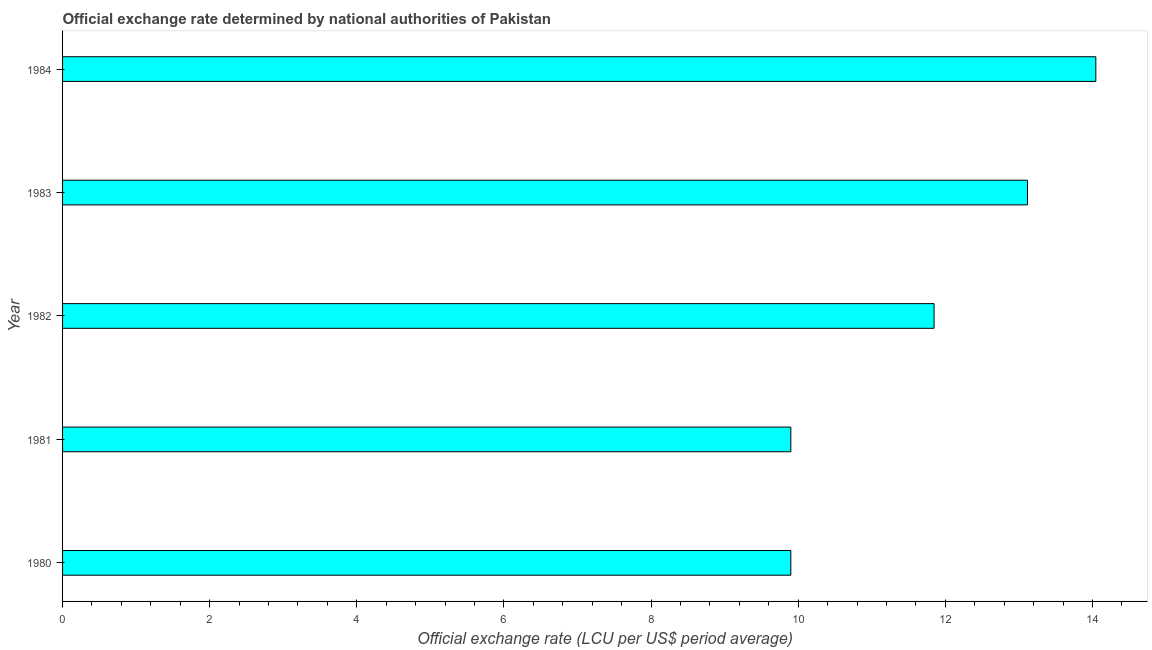Does the graph contain any zero values?
Your response must be concise. No. Does the graph contain grids?
Keep it short and to the point. No. What is the title of the graph?
Make the answer very short. Official exchange rate determined by national authorities of Pakistan. What is the label or title of the X-axis?
Make the answer very short. Official exchange rate (LCU per US$ period average). What is the label or title of the Y-axis?
Offer a very short reply. Year. What is the official exchange rate in 1984?
Provide a succinct answer. 14.05. Across all years, what is the maximum official exchange rate?
Your answer should be very brief. 14.05. Across all years, what is the minimum official exchange rate?
Provide a succinct answer. 9.9. In which year was the official exchange rate minimum?
Keep it short and to the point. 1980. What is the sum of the official exchange rate?
Offer a terse response. 58.81. What is the difference between the official exchange rate in 1981 and 1983?
Provide a succinct answer. -3.22. What is the average official exchange rate per year?
Provide a succinct answer. 11.76. What is the median official exchange rate?
Ensure brevity in your answer.  11.85. In how many years, is the official exchange rate greater than 6 ?
Keep it short and to the point. 5. Do a majority of the years between 1982 and 1981 (inclusive) have official exchange rate greater than 11.6 ?
Your answer should be very brief. No. What is the ratio of the official exchange rate in 1982 to that in 1984?
Give a very brief answer. 0.84. Is the difference between the official exchange rate in 1982 and 1983 greater than the difference between any two years?
Offer a very short reply. No. What is the difference between the highest and the second highest official exchange rate?
Provide a succinct answer. 0.93. Is the sum of the official exchange rate in 1981 and 1983 greater than the maximum official exchange rate across all years?
Offer a terse response. Yes. What is the difference between the highest and the lowest official exchange rate?
Keep it short and to the point. 4.15. In how many years, is the official exchange rate greater than the average official exchange rate taken over all years?
Ensure brevity in your answer.  3. How many bars are there?
Offer a very short reply. 5. What is the difference between two consecutive major ticks on the X-axis?
Your answer should be very brief. 2. What is the Official exchange rate (LCU per US$ period average) in 1981?
Offer a terse response. 9.9. What is the Official exchange rate (LCU per US$ period average) of 1982?
Ensure brevity in your answer.  11.85. What is the Official exchange rate (LCU per US$ period average) of 1983?
Make the answer very short. 13.12. What is the Official exchange rate (LCU per US$ period average) in 1984?
Your answer should be compact. 14.05. What is the difference between the Official exchange rate (LCU per US$ period average) in 1980 and 1981?
Offer a terse response. 0. What is the difference between the Official exchange rate (LCU per US$ period average) in 1980 and 1982?
Offer a terse response. -1.95. What is the difference between the Official exchange rate (LCU per US$ period average) in 1980 and 1983?
Provide a succinct answer. -3.22. What is the difference between the Official exchange rate (LCU per US$ period average) in 1980 and 1984?
Give a very brief answer. -4.15. What is the difference between the Official exchange rate (LCU per US$ period average) in 1981 and 1982?
Offer a very short reply. -1.95. What is the difference between the Official exchange rate (LCU per US$ period average) in 1981 and 1983?
Your response must be concise. -3.22. What is the difference between the Official exchange rate (LCU per US$ period average) in 1981 and 1984?
Provide a succinct answer. -4.15. What is the difference between the Official exchange rate (LCU per US$ period average) in 1982 and 1983?
Keep it short and to the point. -1.27. What is the difference between the Official exchange rate (LCU per US$ period average) in 1982 and 1984?
Your response must be concise. -2.2. What is the difference between the Official exchange rate (LCU per US$ period average) in 1983 and 1984?
Make the answer very short. -0.93. What is the ratio of the Official exchange rate (LCU per US$ period average) in 1980 to that in 1982?
Give a very brief answer. 0.84. What is the ratio of the Official exchange rate (LCU per US$ period average) in 1980 to that in 1983?
Give a very brief answer. 0.76. What is the ratio of the Official exchange rate (LCU per US$ period average) in 1980 to that in 1984?
Keep it short and to the point. 0.7. What is the ratio of the Official exchange rate (LCU per US$ period average) in 1981 to that in 1982?
Your response must be concise. 0.84. What is the ratio of the Official exchange rate (LCU per US$ period average) in 1981 to that in 1983?
Make the answer very short. 0.76. What is the ratio of the Official exchange rate (LCU per US$ period average) in 1981 to that in 1984?
Your answer should be compact. 0.7. What is the ratio of the Official exchange rate (LCU per US$ period average) in 1982 to that in 1983?
Your answer should be very brief. 0.9. What is the ratio of the Official exchange rate (LCU per US$ period average) in 1982 to that in 1984?
Offer a terse response. 0.84. What is the ratio of the Official exchange rate (LCU per US$ period average) in 1983 to that in 1984?
Offer a very short reply. 0.93. 